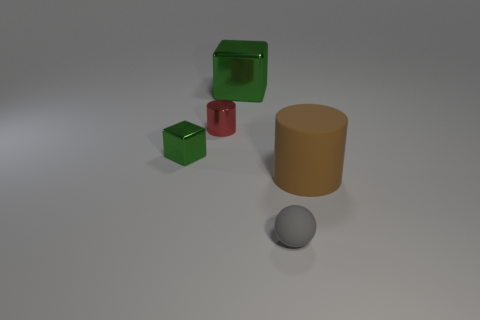Add 3 big rubber balls. How many objects exist? 8 Subtract all blocks. How many objects are left? 3 Subtract 0 yellow spheres. How many objects are left? 5 Subtract all tiny yellow shiny balls. Subtract all red objects. How many objects are left? 4 Add 4 matte balls. How many matte balls are left? 5 Add 4 balls. How many balls exist? 5 